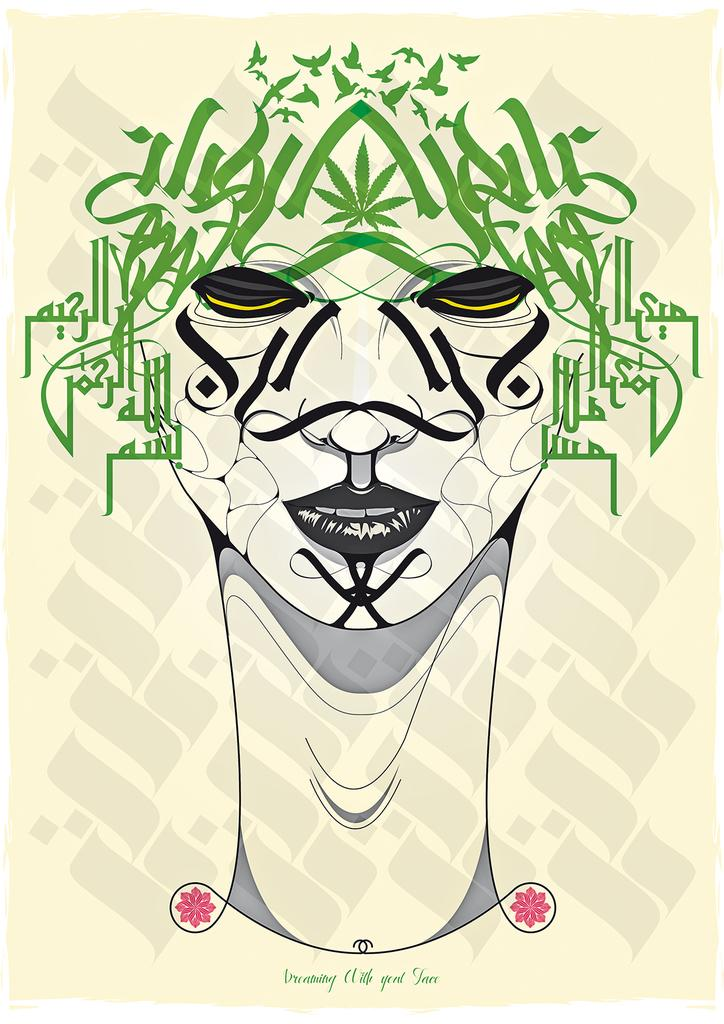What is the main subject of the image? There is a painting in the image. Can you describe any other elements in the image besides the painting? Yes, there is text in the image. What type of thunder can be heard in the image? There is no thunder present in the image, as it is a visual medium and does not contain sound. 